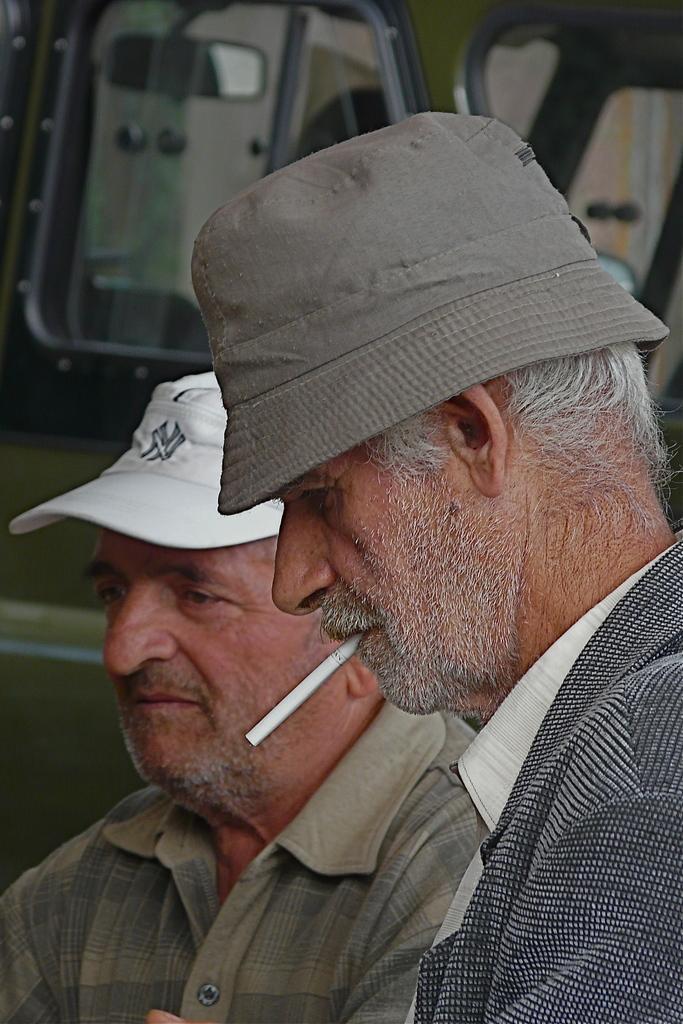Could you give a brief overview of what you see in this image? In this image we can see two men, a person is smoking a cigarette and there is a vehicle in the background. 